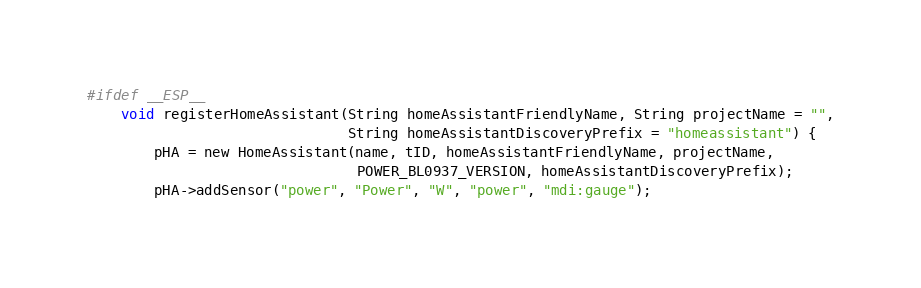<code> <loc_0><loc_0><loc_500><loc_500><_C_>
#ifdef __ESP__
    void registerHomeAssistant(String homeAssistantFriendlyName, String projectName = "",
                               String homeAssistantDiscoveryPrefix = "homeassistant") {
        pHA = new HomeAssistant(name, tID, homeAssistantFriendlyName, projectName,
                                POWER_BL0937_VERSION, homeAssistantDiscoveryPrefix);
        pHA->addSensor("power", "Power", "W", "power", "mdi:gauge");</code> 